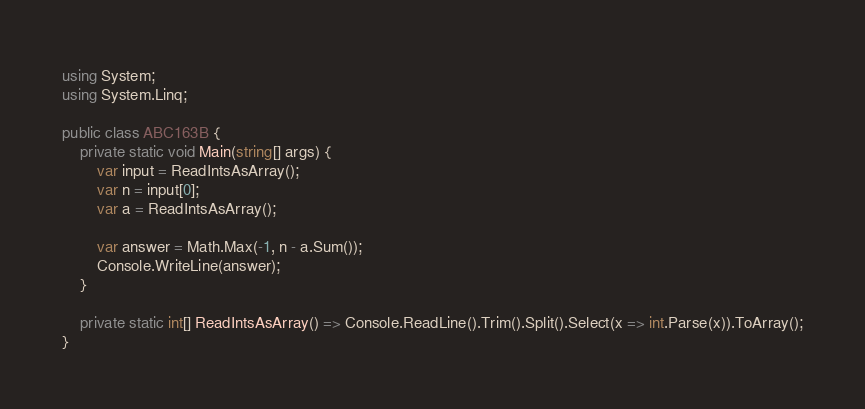Convert code to text. <code><loc_0><loc_0><loc_500><loc_500><_C#_>using System;
using System.Linq;

public class ABC163B {
	private static void Main(string[] args) {
		var input = ReadIntsAsArray();
		var n = input[0];
		var a = ReadIntsAsArray();

		var answer = Math.Max(-1, n - a.Sum());
		Console.WriteLine(answer);
	}

	private static int[] ReadIntsAsArray() => Console.ReadLine().Trim().Split().Select(x => int.Parse(x)).ToArray();
}</code> 